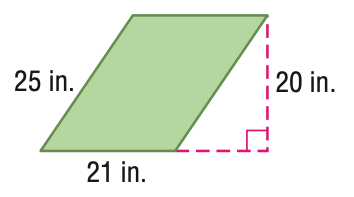Answer the mathemtical geometry problem and directly provide the correct option letter.
Question: Find the perimeter of the parallelogram. Round to the nearest tenth if necessary.
Choices: A: 46 B: 92 C: 184 D: 420 B 